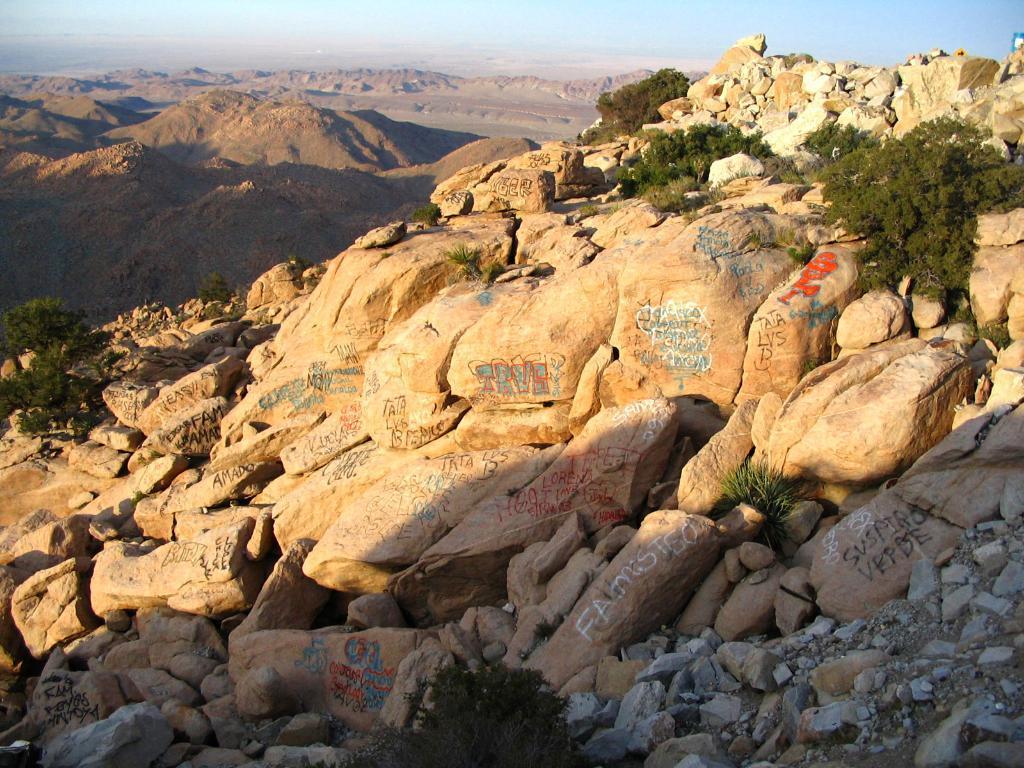How would you summarize this image in a sentence or two? In this picture I can see many mountains. At the bottom I can see the stones. On the right I can see the plants. At the top I can see the sky. 